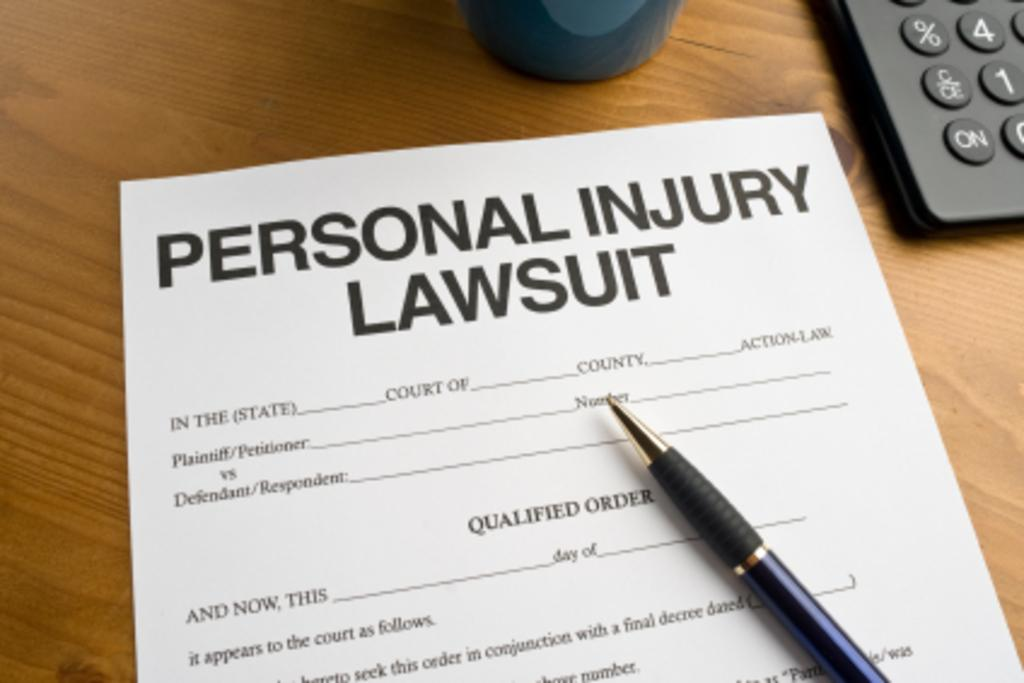Provide a one-sentence caption for the provided image. A pen rests on a Personal Injury Lawsuit form. 